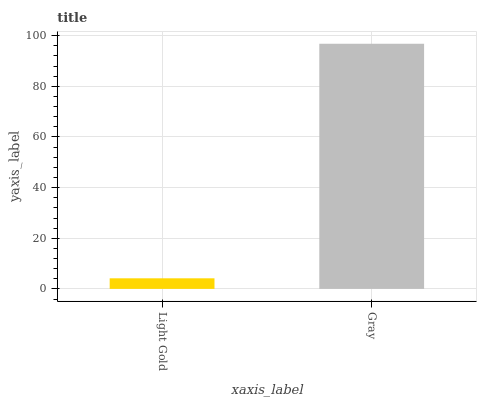Is Light Gold the minimum?
Answer yes or no. Yes. Is Gray the maximum?
Answer yes or no. Yes. Is Gray the minimum?
Answer yes or no. No. Is Gray greater than Light Gold?
Answer yes or no. Yes. Is Light Gold less than Gray?
Answer yes or no. Yes. Is Light Gold greater than Gray?
Answer yes or no. No. Is Gray less than Light Gold?
Answer yes or no. No. Is Gray the high median?
Answer yes or no. Yes. Is Light Gold the low median?
Answer yes or no. Yes. Is Light Gold the high median?
Answer yes or no. No. Is Gray the low median?
Answer yes or no. No. 